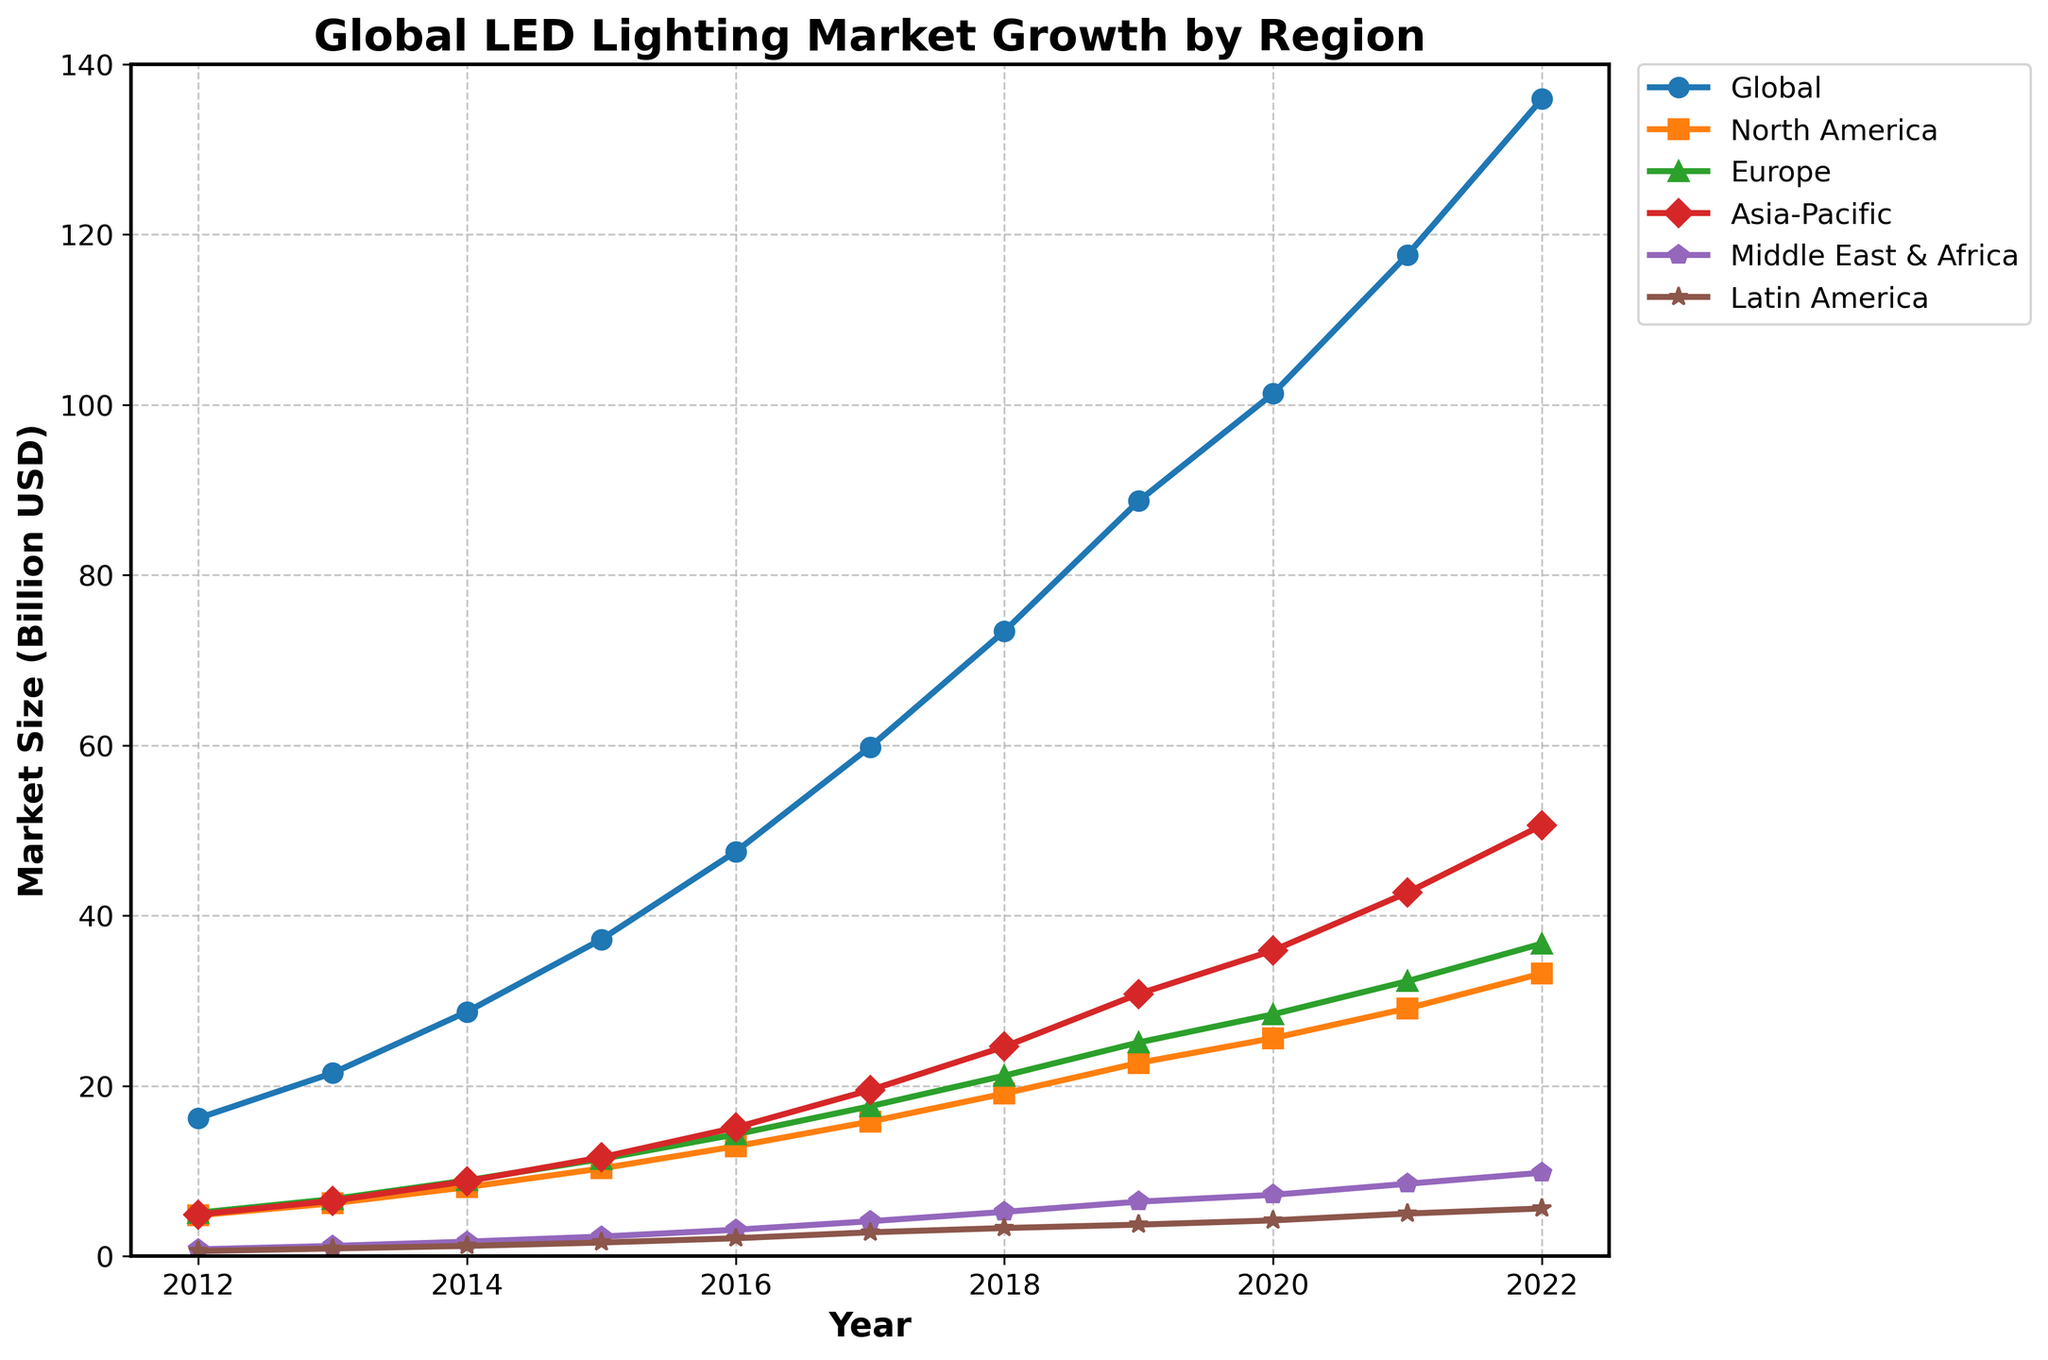What was the total size of the LED lighting market in 2015 for Europe and Asia-Pacific combined? Look at the data points for Europe and Asia-Pacific in 2015. Europe had a market size of 11.4 billion USD, and Asia-Pacific had a market size of 11.6 billion USD. Summing these values gives 11.4 + 11.6 = 23.0 billion USD.
Answer: 23.0 billion USD By how much did the market size in North America grow from 2012 to 2022? Refer to the data points for North America in 2012 and 2022. In 2012, the market size was 4.8 billion USD, and in 2022, it was 33.2 billion USD. The increase in size is calculated as 33.2 - 4.8 = 28.4 billion USD.
Answer: 28.4 billion USD Which region had the smallest market size in 2016 and what was it? Observe the 2016 data points for each region. Middle East & Africa had the smallest market size at 3.1 billion USD.
Answer: Middle East & Africa, 3.1 billion USD Which region showed the most significant increase in market size from 2018 to 2022? Calculate the increase for each region between 2018 and 2022. North America: 33.2 - 19.1 = 14.1; Europe: 36.7 - 21.2 = 15.5; Asia-Pacific: 50.6 - 24.6 = 26.0; Middle East & Africa: 9.8 - 5.2 = 4.6; Latin America: 5.6 - 3.3 = 2.3. Asia-Pacific showed the largest increase, by 26.0 billion USD.
Answer: Asia-Pacific, 26.0 billion USD In which year did the global LED lighting market cross the 50 billion USD mark? Look at the "Global" column for each year. In 2016, the market size was 47.5 billion USD, and in 2017, it increased to 59.8 billion USD. Therefore, it crossed the 50 billion USD mark in 2017.
Answer: 2017 How much more significant was the global market size in 2022 compared to 2012? Refer to the global market sizes for 2012 and 2022. In 2012, it was 16.2 billion USD, and in 2022, it was 135.9 billion USD. The difference is 135.9 - 16.2 = 119.7 billion USD.
Answer: 119.7 billion USD What is the average market size of Latin America over the years 2012 to 2022? Sum the market sizes for Latin America from 2012 to 2022 and divide by the number of years (11). (0.6 + 0.9 + 1.2 + 1.6 + 2.1 + 2.8 + 3.3 + 3.7 + 4.2 + 5.0 + 5.6) / 11 = 31 / 11 ≈ 2.82 billion USD.
Answer: 2.82 billion USD 